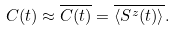<formula> <loc_0><loc_0><loc_500><loc_500>C ( t ) \approx \overline { C ( t ) } = \overline { \langle S ^ { z } ( t ) \rangle } .</formula> 